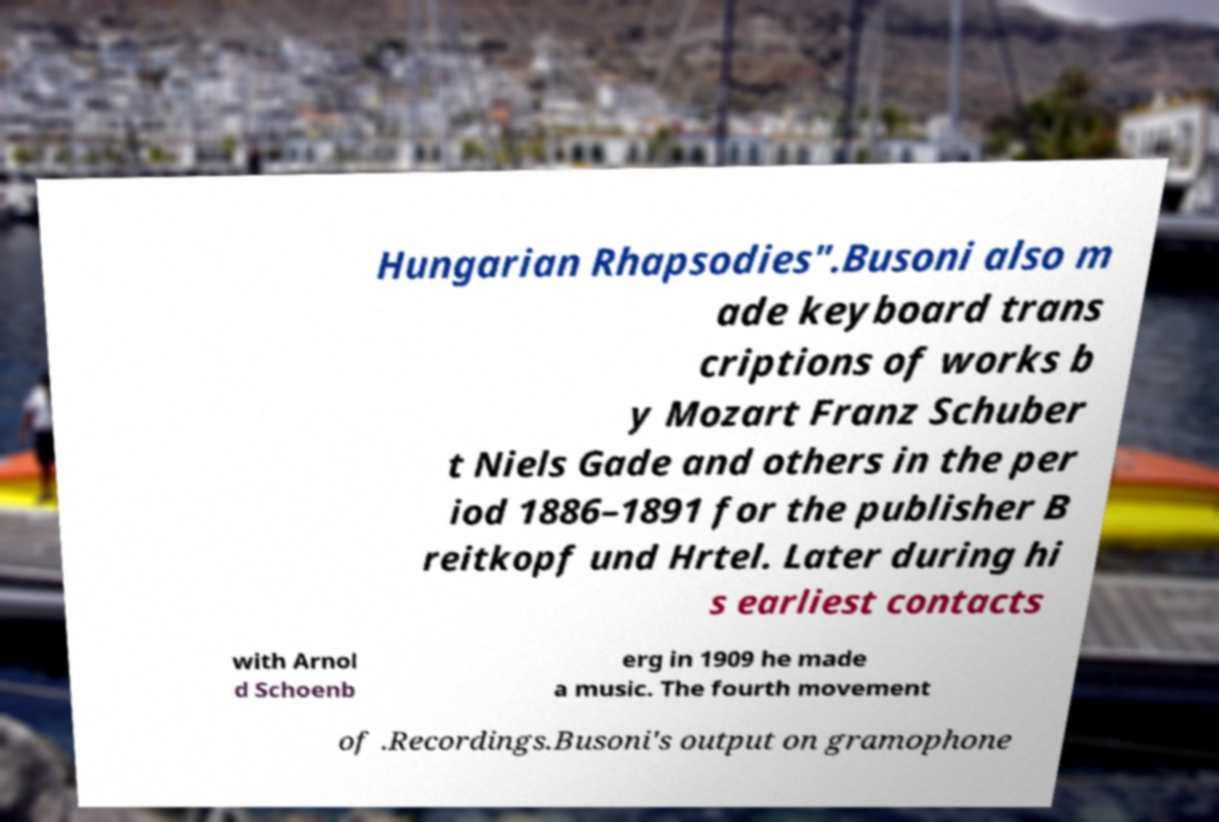For documentation purposes, I need the text within this image transcribed. Could you provide that? Hungarian Rhapsodies".Busoni also m ade keyboard trans criptions of works b y Mozart Franz Schuber t Niels Gade and others in the per iod 1886–1891 for the publisher B reitkopf und Hrtel. Later during hi s earliest contacts with Arnol d Schoenb erg in 1909 he made a music. The fourth movement of .Recordings.Busoni's output on gramophone 